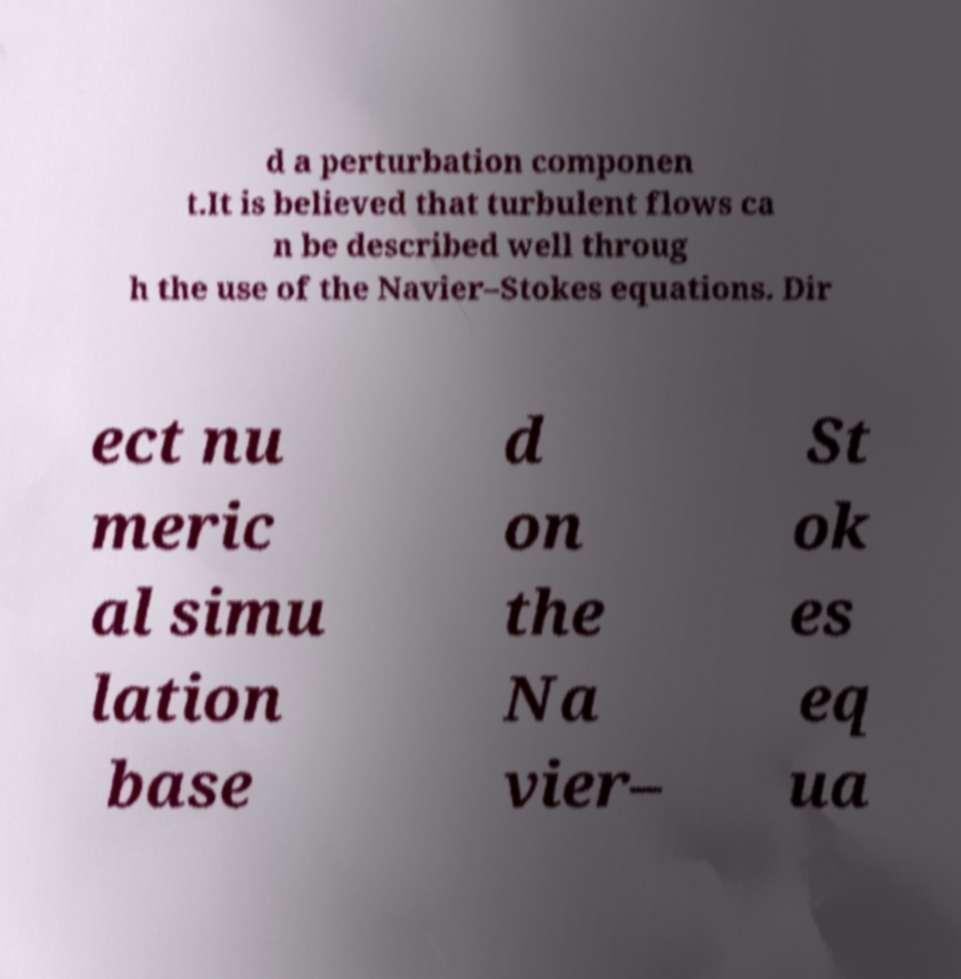Please identify and transcribe the text found in this image. d a perturbation componen t.It is believed that turbulent flows ca n be described well throug h the use of the Navier–Stokes equations. Dir ect nu meric al simu lation base d on the Na vier– St ok es eq ua 